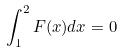<formula> <loc_0><loc_0><loc_500><loc_500>\int _ { 1 } ^ { 2 } F ( x ) d x = 0</formula> 